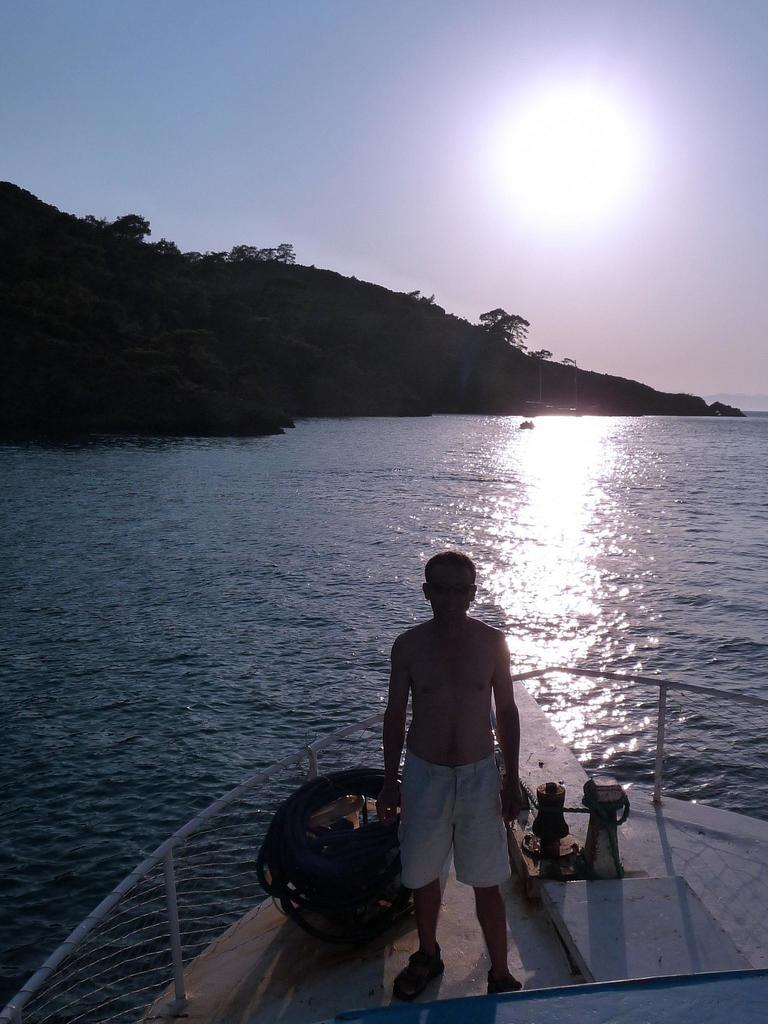Who is present in the image? There is a man in the image. What is the man doing in the image? The man is in a boat. What can be seen in the background of the image? There are hills in the background of the image. What is the primary setting of the image? There is water visible in the image. What religious symbols can be seen in the image? There are no religious symbols present in the image. What time of day is it in the image? The time of day cannot be determined from the image. 